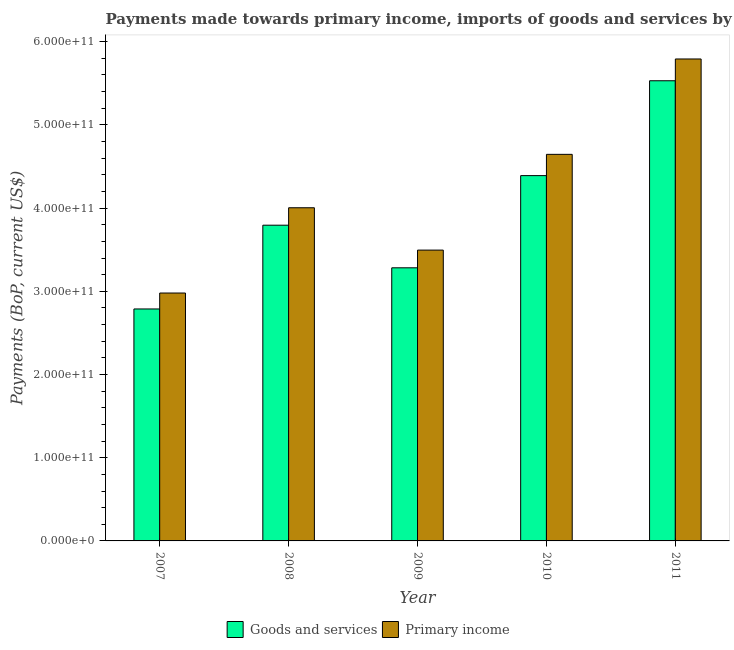Are the number of bars per tick equal to the number of legend labels?
Your answer should be very brief. Yes. How many bars are there on the 4th tick from the left?
Your response must be concise. 2. How many bars are there on the 3rd tick from the right?
Provide a short and direct response. 2. What is the payments made towards primary income in 2007?
Ensure brevity in your answer.  2.98e+11. Across all years, what is the maximum payments made towards goods and services?
Give a very brief answer. 5.53e+11. Across all years, what is the minimum payments made towards primary income?
Make the answer very short. 2.98e+11. What is the total payments made towards primary income in the graph?
Your answer should be very brief. 2.09e+12. What is the difference between the payments made towards goods and services in 2010 and that in 2011?
Offer a terse response. -1.14e+11. What is the difference between the payments made towards primary income in 2011 and the payments made towards goods and services in 2009?
Your answer should be compact. 2.30e+11. What is the average payments made towards primary income per year?
Your response must be concise. 4.18e+11. In the year 2011, what is the difference between the payments made towards primary income and payments made towards goods and services?
Keep it short and to the point. 0. What is the ratio of the payments made towards goods and services in 2009 to that in 2010?
Ensure brevity in your answer.  0.75. Is the payments made towards primary income in 2007 less than that in 2011?
Make the answer very short. Yes. What is the difference between the highest and the second highest payments made towards primary income?
Ensure brevity in your answer.  1.15e+11. What is the difference between the highest and the lowest payments made towards goods and services?
Offer a very short reply. 2.74e+11. In how many years, is the payments made towards primary income greater than the average payments made towards primary income taken over all years?
Provide a succinct answer. 2. What does the 2nd bar from the left in 2008 represents?
Ensure brevity in your answer.  Primary income. What does the 1st bar from the right in 2009 represents?
Your answer should be compact. Primary income. How many bars are there?
Provide a short and direct response. 10. What is the difference between two consecutive major ticks on the Y-axis?
Ensure brevity in your answer.  1.00e+11. Are the values on the major ticks of Y-axis written in scientific E-notation?
Ensure brevity in your answer.  Yes. Does the graph contain any zero values?
Give a very brief answer. No. Does the graph contain grids?
Your answer should be very brief. No. How are the legend labels stacked?
Ensure brevity in your answer.  Horizontal. What is the title of the graph?
Ensure brevity in your answer.  Payments made towards primary income, imports of goods and services by India. What is the label or title of the X-axis?
Keep it short and to the point. Year. What is the label or title of the Y-axis?
Keep it short and to the point. Payments (BoP, current US$). What is the Payments (BoP, current US$) of Goods and services in 2007?
Offer a terse response. 2.79e+11. What is the Payments (BoP, current US$) of Primary income in 2007?
Your response must be concise. 2.98e+11. What is the Payments (BoP, current US$) of Goods and services in 2008?
Keep it short and to the point. 3.79e+11. What is the Payments (BoP, current US$) in Primary income in 2008?
Provide a short and direct response. 4.00e+11. What is the Payments (BoP, current US$) of Goods and services in 2009?
Your response must be concise. 3.28e+11. What is the Payments (BoP, current US$) in Primary income in 2009?
Ensure brevity in your answer.  3.50e+11. What is the Payments (BoP, current US$) of Goods and services in 2010?
Make the answer very short. 4.39e+11. What is the Payments (BoP, current US$) of Primary income in 2010?
Your answer should be very brief. 4.65e+11. What is the Payments (BoP, current US$) in Goods and services in 2011?
Keep it short and to the point. 5.53e+11. What is the Payments (BoP, current US$) of Primary income in 2011?
Offer a very short reply. 5.79e+11. Across all years, what is the maximum Payments (BoP, current US$) of Goods and services?
Keep it short and to the point. 5.53e+11. Across all years, what is the maximum Payments (BoP, current US$) in Primary income?
Your response must be concise. 5.79e+11. Across all years, what is the minimum Payments (BoP, current US$) of Goods and services?
Your answer should be very brief. 2.79e+11. Across all years, what is the minimum Payments (BoP, current US$) of Primary income?
Offer a terse response. 2.98e+11. What is the total Payments (BoP, current US$) of Goods and services in the graph?
Offer a terse response. 1.98e+12. What is the total Payments (BoP, current US$) of Primary income in the graph?
Your answer should be compact. 2.09e+12. What is the difference between the Payments (BoP, current US$) of Goods and services in 2007 and that in 2008?
Make the answer very short. -1.01e+11. What is the difference between the Payments (BoP, current US$) in Primary income in 2007 and that in 2008?
Provide a succinct answer. -1.02e+11. What is the difference between the Payments (BoP, current US$) in Goods and services in 2007 and that in 2009?
Provide a succinct answer. -4.95e+1. What is the difference between the Payments (BoP, current US$) in Primary income in 2007 and that in 2009?
Your answer should be very brief. -5.16e+1. What is the difference between the Payments (BoP, current US$) of Goods and services in 2007 and that in 2010?
Make the answer very short. -1.60e+11. What is the difference between the Payments (BoP, current US$) in Primary income in 2007 and that in 2010?
Provide a short and direct response. -1.67e+11. What is the difference between the Payments (BoP, current US$) in Goods and services in 2007 and that in 2011?
Offer a very short reply. -2.74e+11. What is the difference between the Payments (BoP, current US$) of Primary income in 2007 and that in 2011?
Your answer should be compact. -2.81e+11. What is the difference between the Payments (BoP, current US$) in Goods and services in 2008 and that in 2009?
Offer a terse response. 5.12e+1. What is the difference between the Payments (BoP, current US$) of Primary income in 2008 and that in 2009?
Your answer should be compact. 5.09e+1. What is the difference between the Payments (BoP, current US$) of Goods and services in 2008 and that in 2010?
Offer a terse response. -5.96e+1. What is the difference between the Payments (BoP, current US$) in Primary income in 2008 and that in 2010?
Offer a terse response. -6.42e+1. What is the difference between the Payments (BoP, current US$) of Goods and services in 2008 and that in 2011?
Offer a very short reply. -1.74e+11. What is the difference between the Payments (BoP, current US$) in Primary income in 2008 and that in 2011?
Your answer should be compact. -1.79e+11. What is the difference between the Payments (BoP, current US$) in Goods and services in 2009 and that in 2010?
Provide a succinct answer. -1.11e+11. What is the difference between the Payments (BoP, current US$) of Primary income in 2009 and that in 2010?
Ensure brevity in your answer.  -1.15e+11. What is the difference between the Payments (BoP, current US$) of Goods and services in 2009 and that in 2011?
Offer a very short reply. -2.25e+11. What is the difference between the Payments (BoP, current US$) in Primary income in 2009 and that in 2011?
Give a very brief answer. -2.30e+11. What is the difference between the Payments (BoP, current US$) of Goods and services in 2010 and that in 2011?
Provide a succinct answer. -1.14e+11. What is the difference between the Payments (BoP, current US$) in Primary income in 2010 and that in 2011?
Provide a short and direct response. -1.15e+11. What is the difference between the Payments (BoP, current US$) of Goods and services in 2007 and the Payments (BoP, current US$) of Primary income in 2008?
Offer a very short reply. -1.22e+11. What is the difference between the Payments (BoP, current US$) in Goods and services in 2007 and the Payments (BoP, current US$) in Primary income in 2009?
Ensure brevity in your answer.  -7.07e+1. What is the difference between the Payments (BoP, current US$) of Goods and services in 2007 and the Payments (BoP, current US$) of Primary income in 2010?
Your answer should be compact. -1.86e+11. What is the difference between the Payments (BoP, current US$) of Goods and services in 2007 and the Payments (BoP, current US$) of Primary income in 2011?
Offer a very short reply. -3.00e+11. What is the difference between the Payments (BoP, current US$) in Goods and services in 2008 and the Payments (BoP, current US$) in Primary income in 2009?
Ensure brevity in your answer.  3.00e+1. What is the difference between the Payments (BoP, current US$) of Goods and services in 2008 and the Payments (BoP, current US$) of Primary income in 2010?
Give a very brief answer. -8.51e+1. What is the difference between the Payments (BoP, current US$) of Goods and services in 2008 and the Payments (BoP, current US$) of Primary income in 2011?
Keep it short and to the point. -2.00e+11. What is the difference between the Payments (BoP, current US$) in Goods and services in 2009 and the Payments (BoP, current US$) in Primary income in 2010?
Provide a short and direct response. -1.36e+11. What is the difference between the Payments (BoP, current US$) of Goods and services in 2009 and the Payments (BoP, current US$) of Primary income in 2011?
Provide a succinct answer. -2.51e+11. What is the difference between the Payments (BoP, current US$) in Goods and services in 2010 and the Payments (BoP, current US$) in Primary income in 2011?
Keep it short and to the point. -1.40e+11. What is the average Payments (BoP, current US$) of Goods and services per year?
Provide a short and direct response. 3.96e+11. What is the average Payments (BoP, current US$) of Primary income per year?
Make the answer very short. 4.18e+11. In the year 2007, what is the difference between the Payments (BoP, current US$) in Goods and services and Payments (BoP, current US$) in Primary income?
Your answer should be very brief. -1.92e+1. In the year 2008, what is the difference between the Payments (BoP, current US$) in Goods and services and Payments (BoP, current US$) in Primary income?
Give a very brief answer. -2.10e+1. In the year 2009, what is the difference between the Payments (BoP, current US$) of Goods and services and Payments (BoP, current US$) of Primary income?
Keep it short and to the point. -2.13e+1. In the year 2010, what is the difference between the Payments (BoP, current US$) of Goods and services and Payments (BoP, current US$) of Primary income?
Offer a very short reply. -2.56e+1. In the year 2011, what is the difference between the Payments (BoP, current US$) in Goods and services and Payments (BoP, current US$) in Primary income?
Offer a terse response. -2.62e+1. What is the ratio of the Payments (BoP, current US$) of Goods and services in 2007 to that in 2008?
Your answer should be compact. 0.73. What is the ratio of the Payments (BoP, current US$) of Primary income in 2007 to that in 2008?
Make the answer very short. 0.74. What is the ratio of the Payments (BoP, current US$) in Goods and services in 2007 to that in 2009?
Provide a short and direct response. 0.85. What is the ratio of the Payments (BoP, current US$) of Primary income in 2007 to that in 2009?
Your response must be concise. 0.85. What is the ratio of the Payments (BoP, current US$) in Goods and services in 2007 to that in 2010?
Provide a short and direct response. 0.64. What is the ratio of the Payments (BoP, current US$) in Primary income in 2007 to that in 2010?
Offer a terse response. 0.64. What is the ratio of the Payments (BoP, current US$) in Goods and services in 2007 to that in 2011?
Your answer should be very brief. 0.5. What is the ratio of the Payments (BoP, current US$) of Primary income in 2007 to that in 2011?
Your answer should be compact. 0.51. What is the ratio of the Payments (BoP, current US$) of Goods and services in 2008 to that in 2009?
Your response must be concise. 1.16. What is the ratio of the Payments (BoP, current US$) of Primary income in 2008 to that in 2009?
Offer a very short reply. 1.15. What is the ratio of the Payments (BoP, current US$) of Goods and services in 2008 to that in 2010?
Offer a terse response. 0.86. What is the ratio of the Payments (BoP, current US$) of Primary income in 2008 to that in 2010?
Offer a very short reply. 0.86. What is the ratio of the Payments (BoP, current US$) in Goods and services in 2008 to that in 2011?
Provide a succinct answer. 0.69. What is the ratio of the Payments (BoP, current US$) of Primary income in 2008 to that in 2011?
Your answer should be very brief. 0.69. What is the ratio of the Payments (BoP, current US$) in Goods and services in 2009 to that in 2010?
Provide a short and direct response. 0.75. What is the ratio of the Payments (BoP, current US$) in Primary income in 2009 to that in 2010?
Your answer should be very brief. 0.75. What is the ratio of the Payments (BoP, current US$) of Goods and services in 2009 to that in 2011?
Give a very brief answer. 0.59. What is the ratio of the Payments (BoP, current US$) in Primary income in 2009 to that in 2011?
Provide a short and direct response. 0.6. What is the ratio of the Payments (BoP, current US$) in Goods and services in 2010 to that in 2011?
Provide a succinct answer. 0.79. What is the ratio of the Payments (BoP, current US$) in Primary income in 2010 to that in 2011?
Provide a succinct answer. 0.8. What is the difference between the highest and the second highest Payments (BoP, current US$) in Goods and services?
Provide a short and direct response. 1.14e+11. What is the difference between the highest and the second highest Payments (BoP, current US$) in Primary income?
Ensure brevity in your answer.  1.15e+11. What is the difference between the highest and the lowest Payments (BoP, current US$) of Goods and services?
Your answer should be compact. 2.74e+11. What is the difference between the highest and the lowest Payments (BoP, current US$) of Primary income?
Your answer should be very brief. 2.81e+11. 